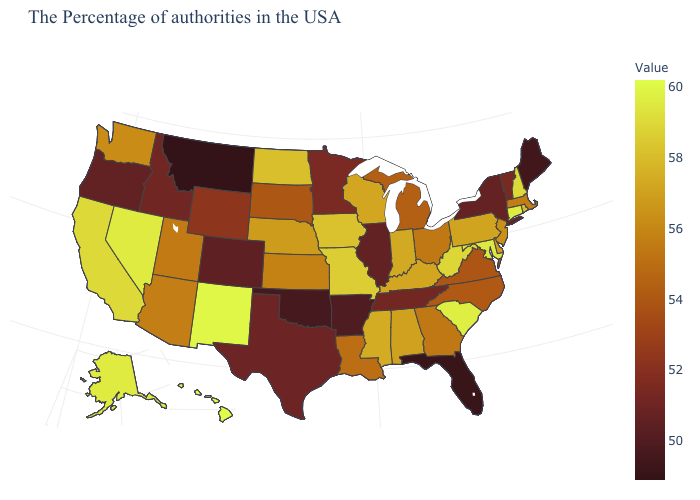Does Minnesota have the lowest value in the MidWest?
Quick response, please. No. Does Texas have a higher value than Maryland?
Be succinct. No. Among the states that border Washington , does Idaho have the highest value?
Write a very short answer. Yes. 